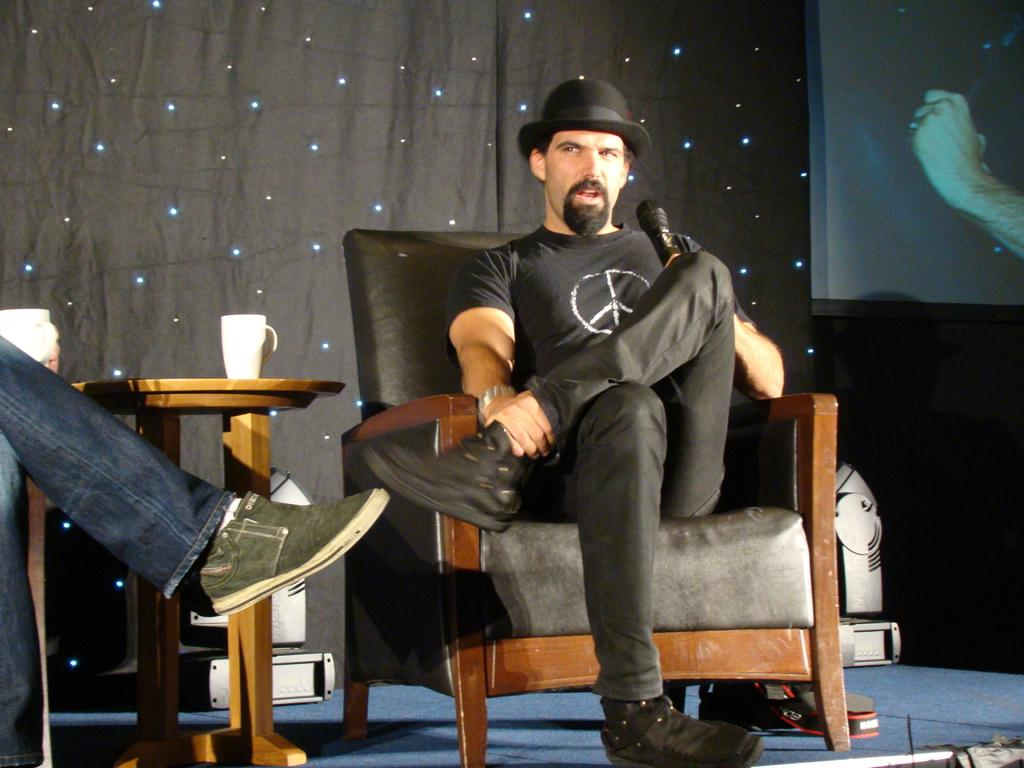Who is present in the image? There is a man in the image. What is the man doing in the image? The man is sitting on a chair and holding a microphone in his hand. What other objects can be seen in the image? There is a table and a cup on the table in the image. What type of bead is the man wearing around his neck in the image? There is no bead visible around the man's neck in the image. What part of the brain is the man using to hold the microphone in the image? The image does not show the man's brain, and holding a microphone does not involve specific brain functions. --- 